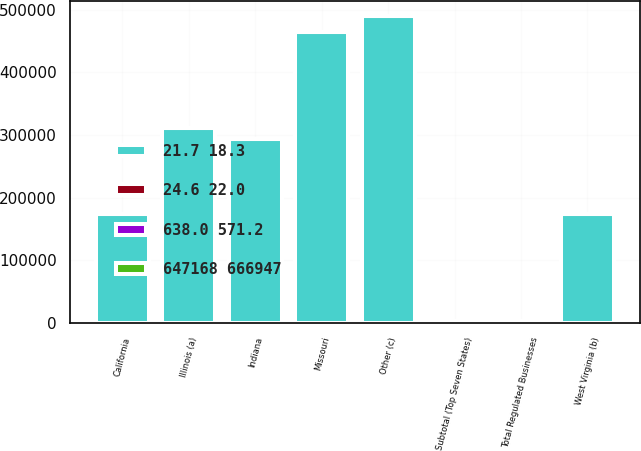Convert chart to OTSL. <chart><loc_0><loc_0><loc_500><loc_500><stacked_bar_chart><ecel><fcel>Missouri<fcel>Illinois (a)<fcel>California<fcel>Indiana<fcel>West Virginia (b)<fcel>Subtotal (Top Seven States)<fcel>Other (c)<fcel>Total Regulated Businesses<nl><fcel>647168 666947<fcel>264.8<fcel>261.7<fcel>209.5<fcel>199.2<fcel>124.2<fcel>2268.6<fcel>325.3<fcel>2593.9<nl><fcel>24.6 22.0<fcel>10.2<fcel>10.1<fcel>8.1<fcel>7.7<fcel>4.8<fcel>87.5<fcel>12.5<fcel>100<nl><fcel>21.7 18.3<fcel>464232<fcel>311464<fcel>173986<fcel>293345<fcel>173208<fcel>100<fcel>489149<fcel>100<nl><fcel>638.0 571.2<fcel>14.4<fcel>9.7<fcel>5.4<fcel>9.1<fcel>5.4<fcel>84.8<fcel>15.2<fcel>100<nl></chart> 